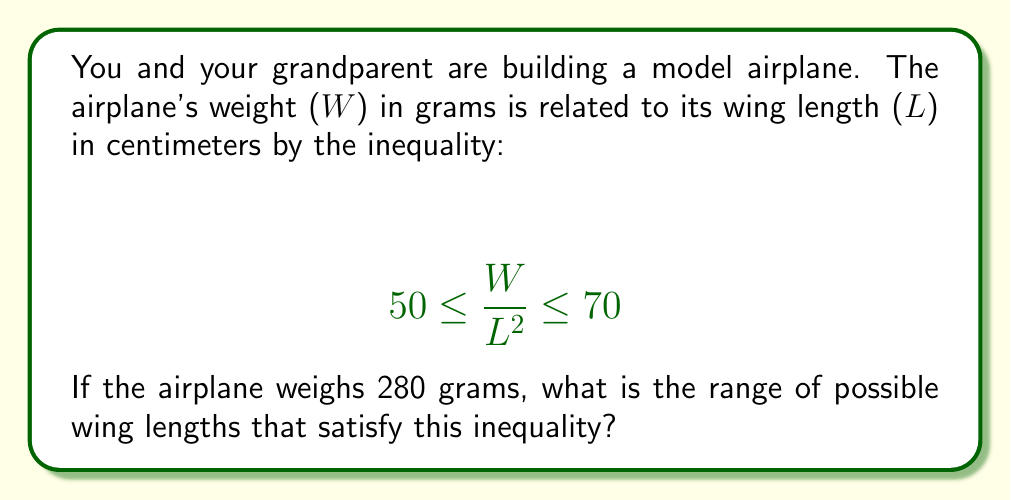Could you help me with this problem? Let's approach this step-by-step:

1) We're given that the weight W = 280 grams. We need to find the range of L that satisfies the inequality.

2) Let's substitute W = 280 into the original inequality:

   $$ 50 \leq \frac{280}{L^2} \leq 70 $$

3) To solve for L, we need to flip the inequality and take the reciprocal of each part. When we do this, the inequality signs flip:

   $$ \frac{1}{70} \leq \frac{L^2}{280} \leq \frac{1}{50} $$

4) Now, let's multiply each part by 280:

   $$ \frac{280}{70} \leq L^2 \leq \frac{280}{50} $$

5) Simplify:

   $$ 4 \leq L^2 \leq 5.6 $$

6) To solve for L, we take the square root of each part. Remember, since L represents length, it must be positive, so we only consider the positive square root:

   $$ \sqrt{4} \leq L \leq \sqrt{5.6} $$

7) Simplify:

   $$ 2 \leq L \leq 2.37 $$

Therefore, the wing length L must be between 2 cm and 2.37 cm, inclusive.
Answer: The range of possible wing lengths is $2 \leq L \leq 2.37$ cm. 